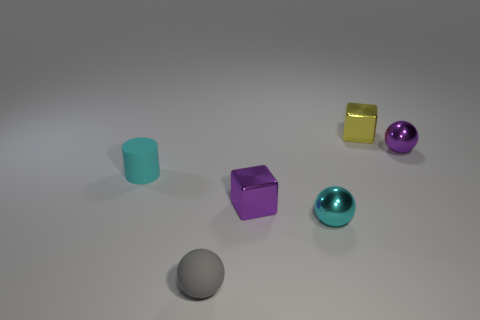What is the color of the other metallic sphere that is the same size as the purple sphere? The sphere that is the same size as the purple sphere has a vibrant cyan color, sharing a similar lustrous finish and reflecting the ambient light softly. 